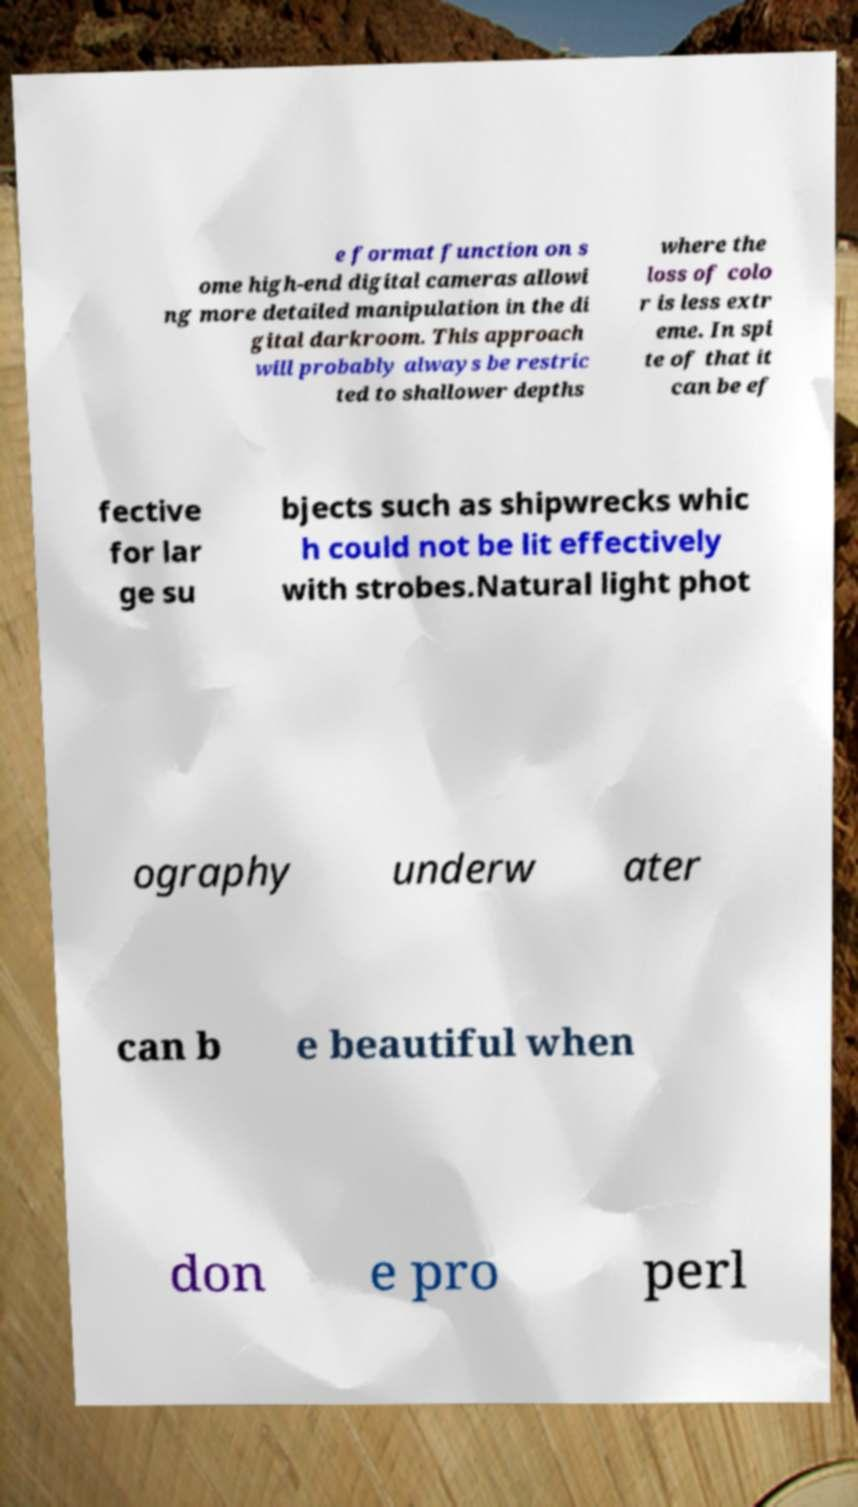Please read and relay the text visible in this image. What does it say? e format function on s ome high-end digital cameras allowi ng more detailed manipulation in the di gital darkroom. This approach will probably always be restric ted to shallower depths where the loss of colo r is less extr eme. In spi te of that it can be ef fective for lar ge su bjects such as shipwrecks whic h could not be lit effectively with strobes.Natural light phot ography underw ater can b e beautiful when don e pro perl 